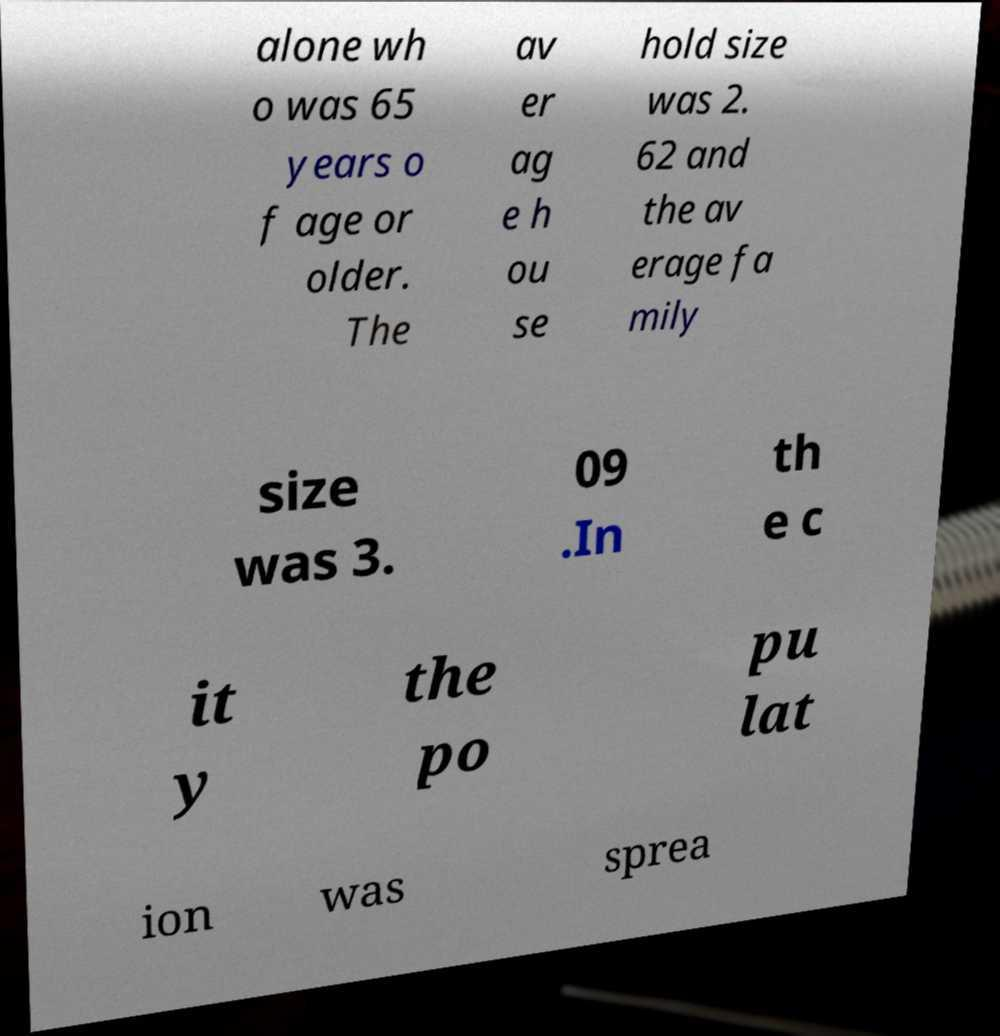Please read and relay the text visible in this image. What does it say? alone wh o was 65 years o f age or older. The av er ag e h ou se hold size was 2. 62 and the av erage fa mily size was 3. 09 .In th e c it y the po pu lat ion was sprea 